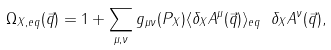<formula> <loc_0><loc_0><loc_500><loc_500>\Omega _ { X , e q } ( \vec { q } ) = 1 + \sum _ { \mu , \nu } g _ { \mu \nu } ( P _ { X } ) \langle \delta _ { X } A ^ { \mu } ( \vec { q } ) \rangle _ { e q } \ \delta _ { X } A ^ { \nu } ( \vec { q } ) ,</formula> 